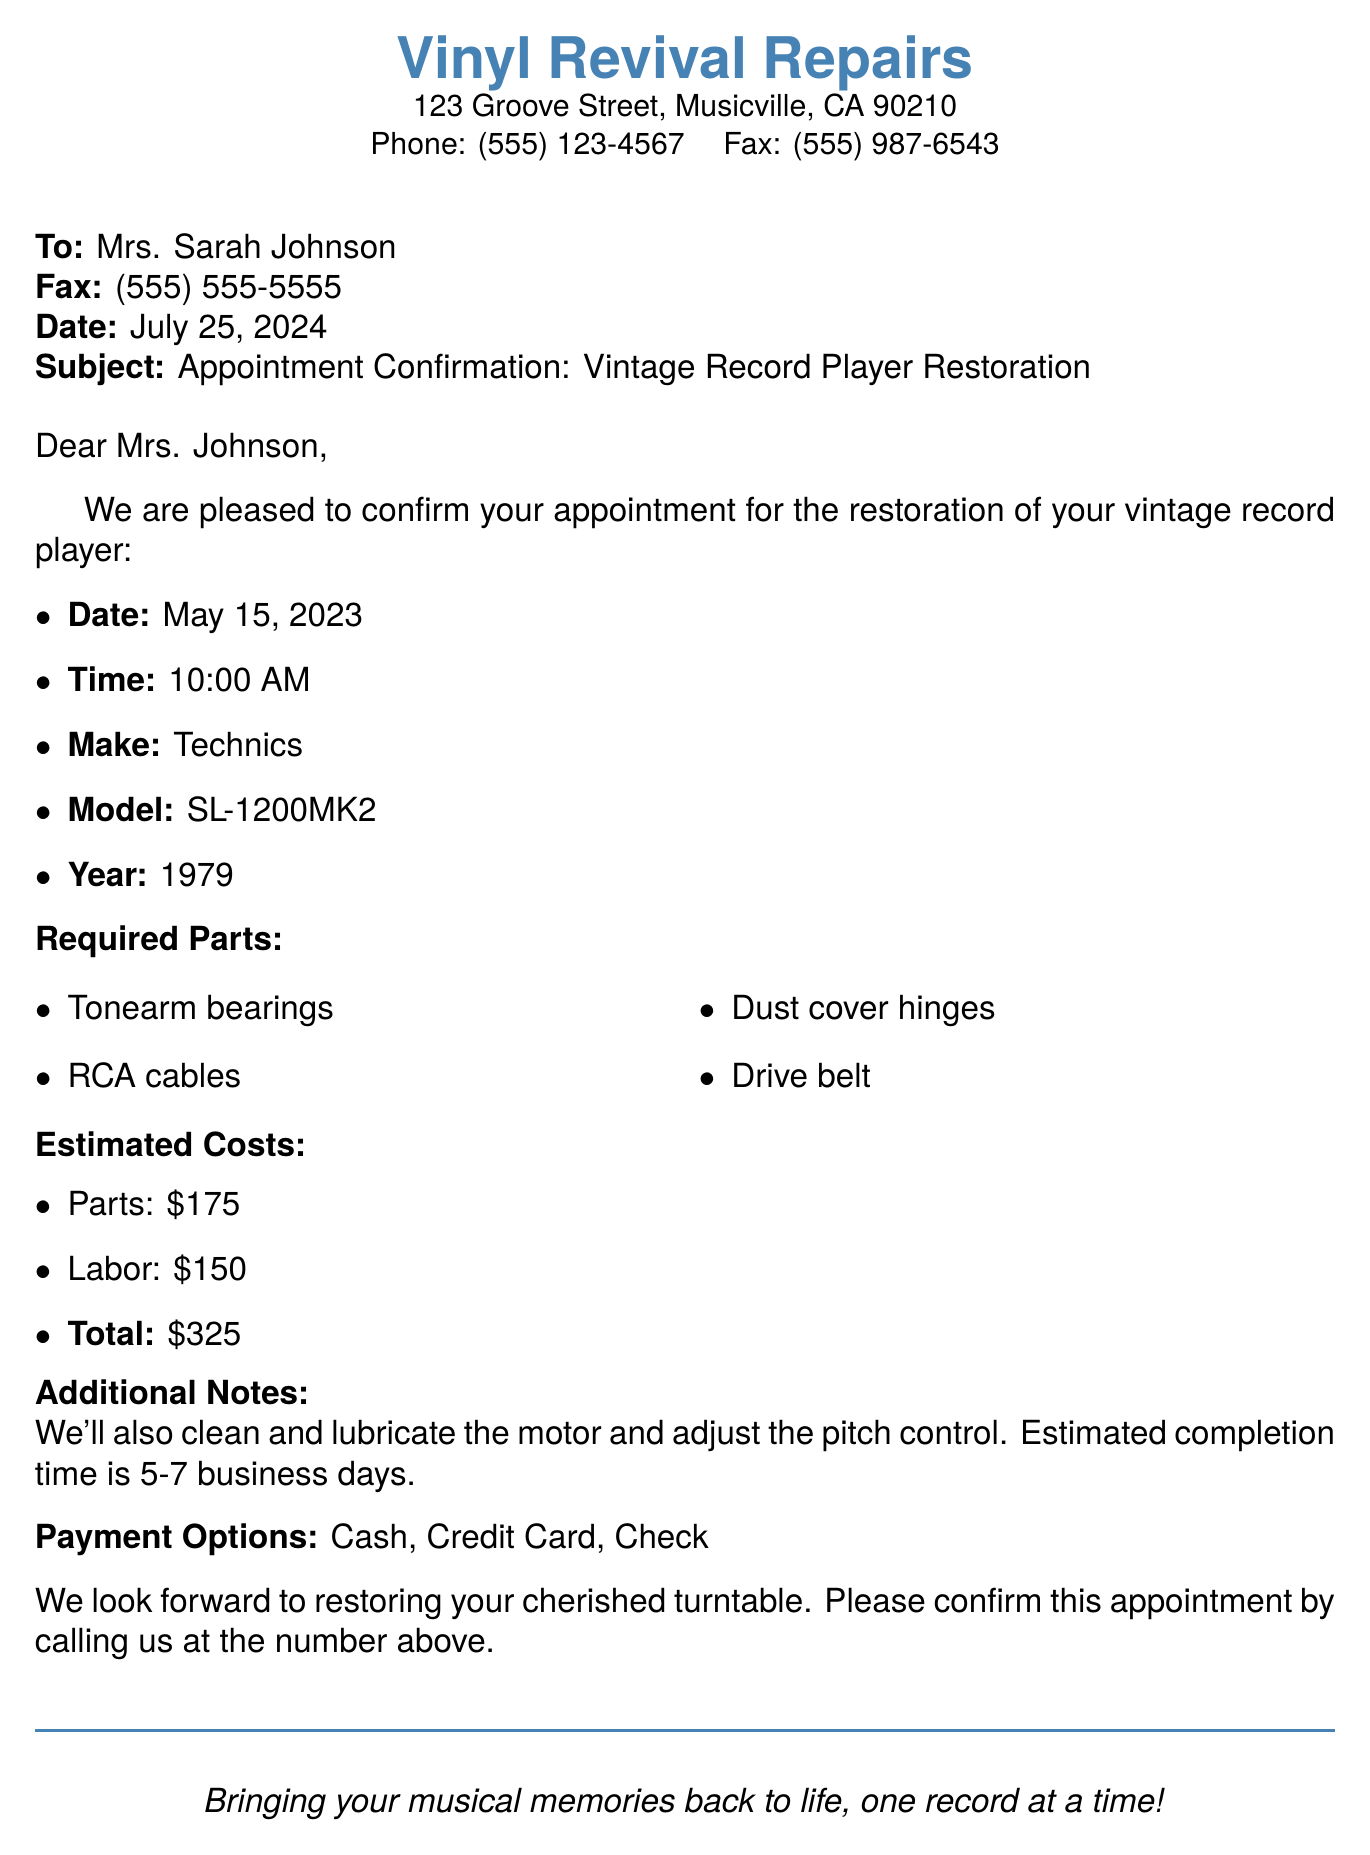what is the appointment date? The appointment date is specified in the document as May 15, 2023.
Answer: May 15, 2023 what time is the appointment scheduled for? The time of the appointment is stated as 10:00 AM in the document.
Answer: 10:00 AM what is the estimated total cost for the restoration? The total cost is provided in the document and is the sum of parts and labor, which is $325.
Answer: $325 what model is the vintage record player? The model of the vintage record player mentioned in the document is SL-1200MK2.
Answer: SL-1200MK2 how many parts are listed as required for the restoration? The document lists four required parts for the restoration of the vintage record player.
Answer: 4 what is the make of the record player? The make of the record player is Technics, as stated in the document.
Answer: Technics what additional service is mentioned besides parts replacement? The document mentions cleaning and lubricating the motor as an additional service.
Answer: cleaning and lubricating the motor how long is the estimated completion time? The estimated completion time given in the document is 5-7 business days.
Answer: 5-7 business days what are the payment options available? The payment options listed in the document are cash, credit card, and check.
Answer: Cash, Credit Card, Check 